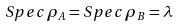Convert formula to latex. <formula><loc_0><loc_0><loc_500><loc_500>S p e c \, \rho _ { A } = S p e c \, \rho _ { B } = \lambda</formula> 